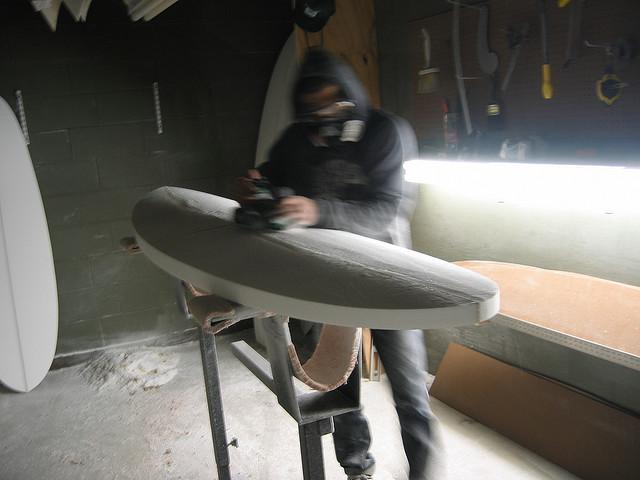What is the man wearing on his head?
Indicate the correct response by choosing from the four available options to answer the question.
Options: Helmet, hat, glasses, hood. Hood. 